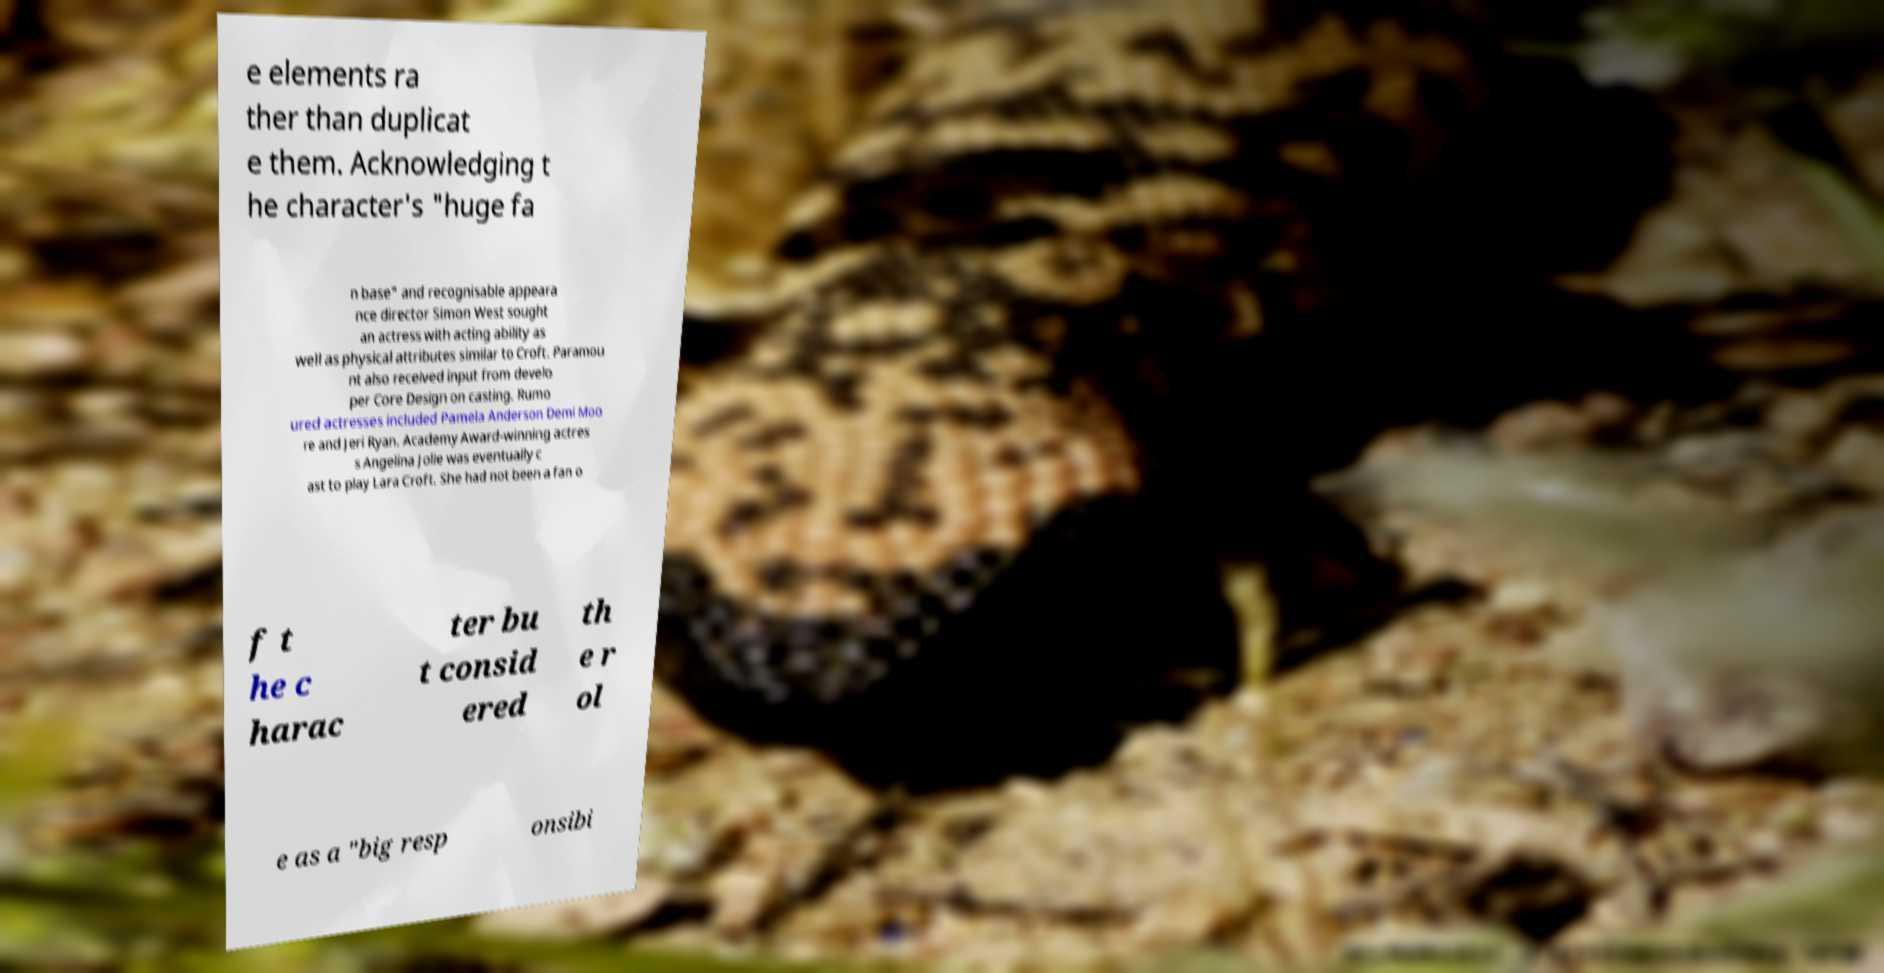What messages or text are displayed in this image? I need them in a readable, typed format. e elements ra ther than duplicat e them. Acknowledging t he character's "huge fa n base" and recognisable appeara nce director Simon West sought an actress with acting ability as well as physical attributes similar to Croft. Paramou nt also received input from develo per Core Design on casting. Rumo ured actresses included Pamela Anderson Demi Moo re and Jeri Ryan. Academy Award-winning actres s Angelina Jolie was eventually c ast to play Lara Croft. She had not been a fan o f t he c harac ter bu t consid ered th e r ol e as a "big resp onsibi 